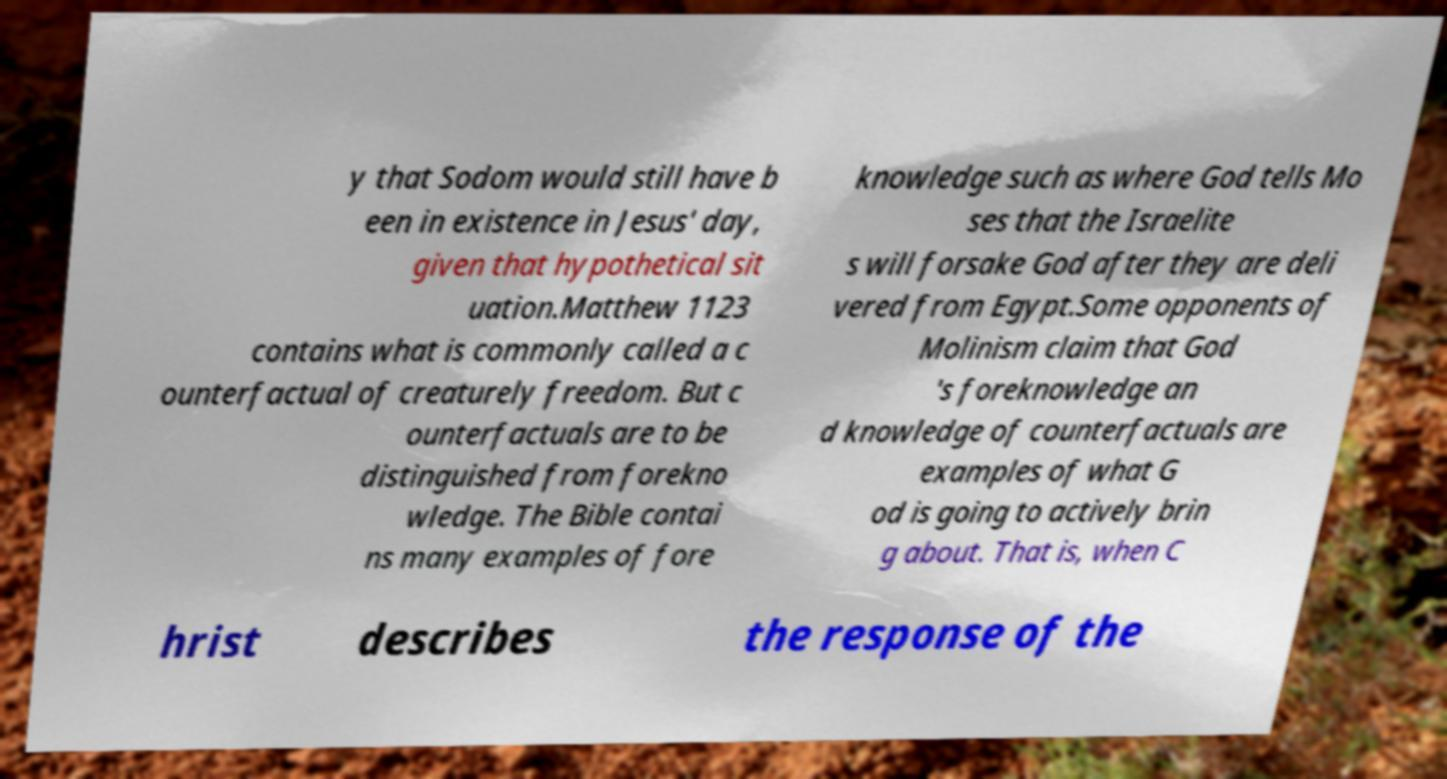For documentation purposes, I need the text within this image transcribed. Could you provide that? y that Sodom would still have b een in existence in Jesus' day, given that hypothetical sit uation.Matthew 1123 contains what is commonly called a c ounterfactual of creaturely freedom. But c ounterfactuals are to be distinguished from forekno wledge. The Bible contai ns many examples of fore knowledge such as where God tells Mo ses that the Israelite s will forsake God after they are deli vered from Egypt.Some opponents of Molinism claim that God 's foreknowledge an d knowledge of counterfactuals are examples of what G od is going to actively brin g about. That is, when C hrist describes the response of the 